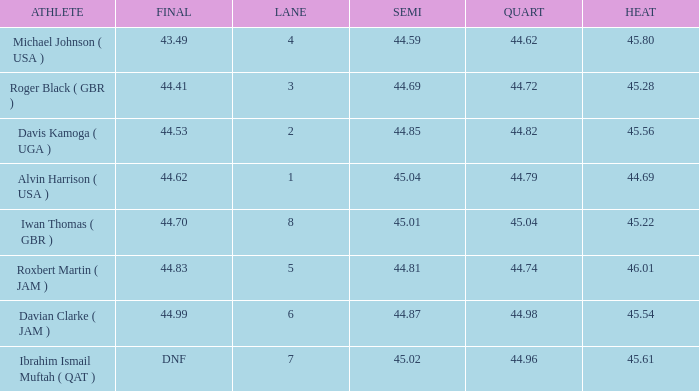62, what is the smallest heat? None. 